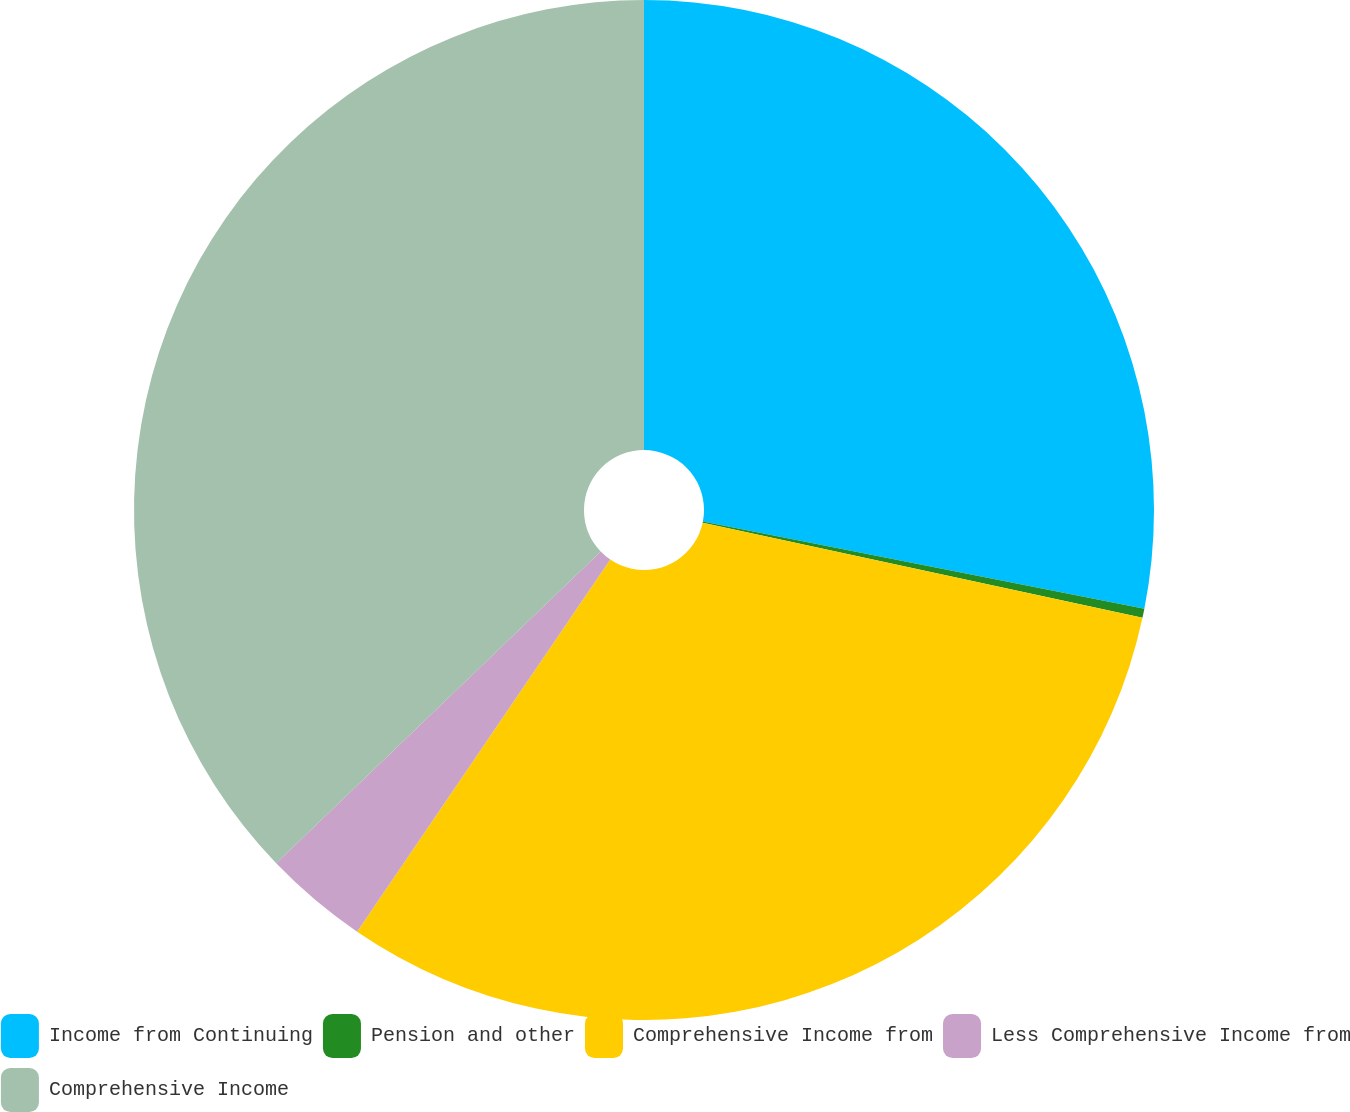Convert chart to OTSL. <chart><loc_0><loc_0><loc_500><loc_500><pie_chart><fcel>Income from Continuing<fcel>Pension and other<fcel>Comprehensive Income from<fcel>Less Comprehensive Income from<fcel>Comprehensive Income<nl><fcel>28.1%<fcel>0.29%<fcel>31.12%<fcel>3.31%<fcel>37.18%<nl></chart> 